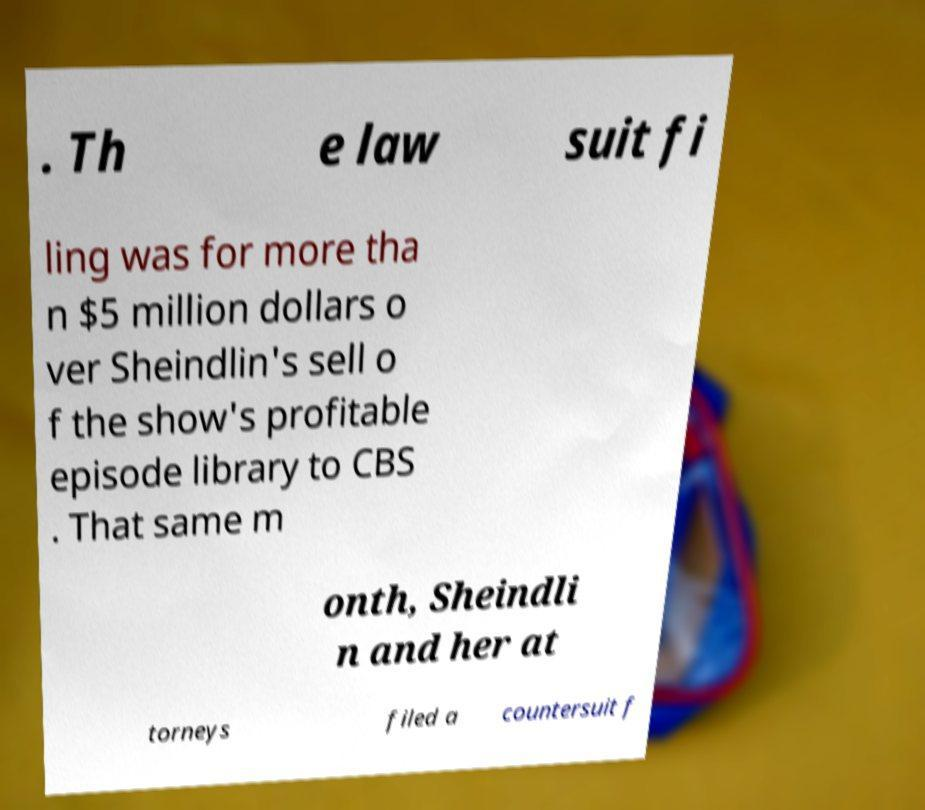I need the written content from this picture converted into text. Can you do that? . Th e law suit fi ling was for more tha n $5 million dollars o ver Sheindlin's sell o f the show's profitable episode library to CBS . That same m onth, Sheindli n and her at torneys filed a countersuit f 